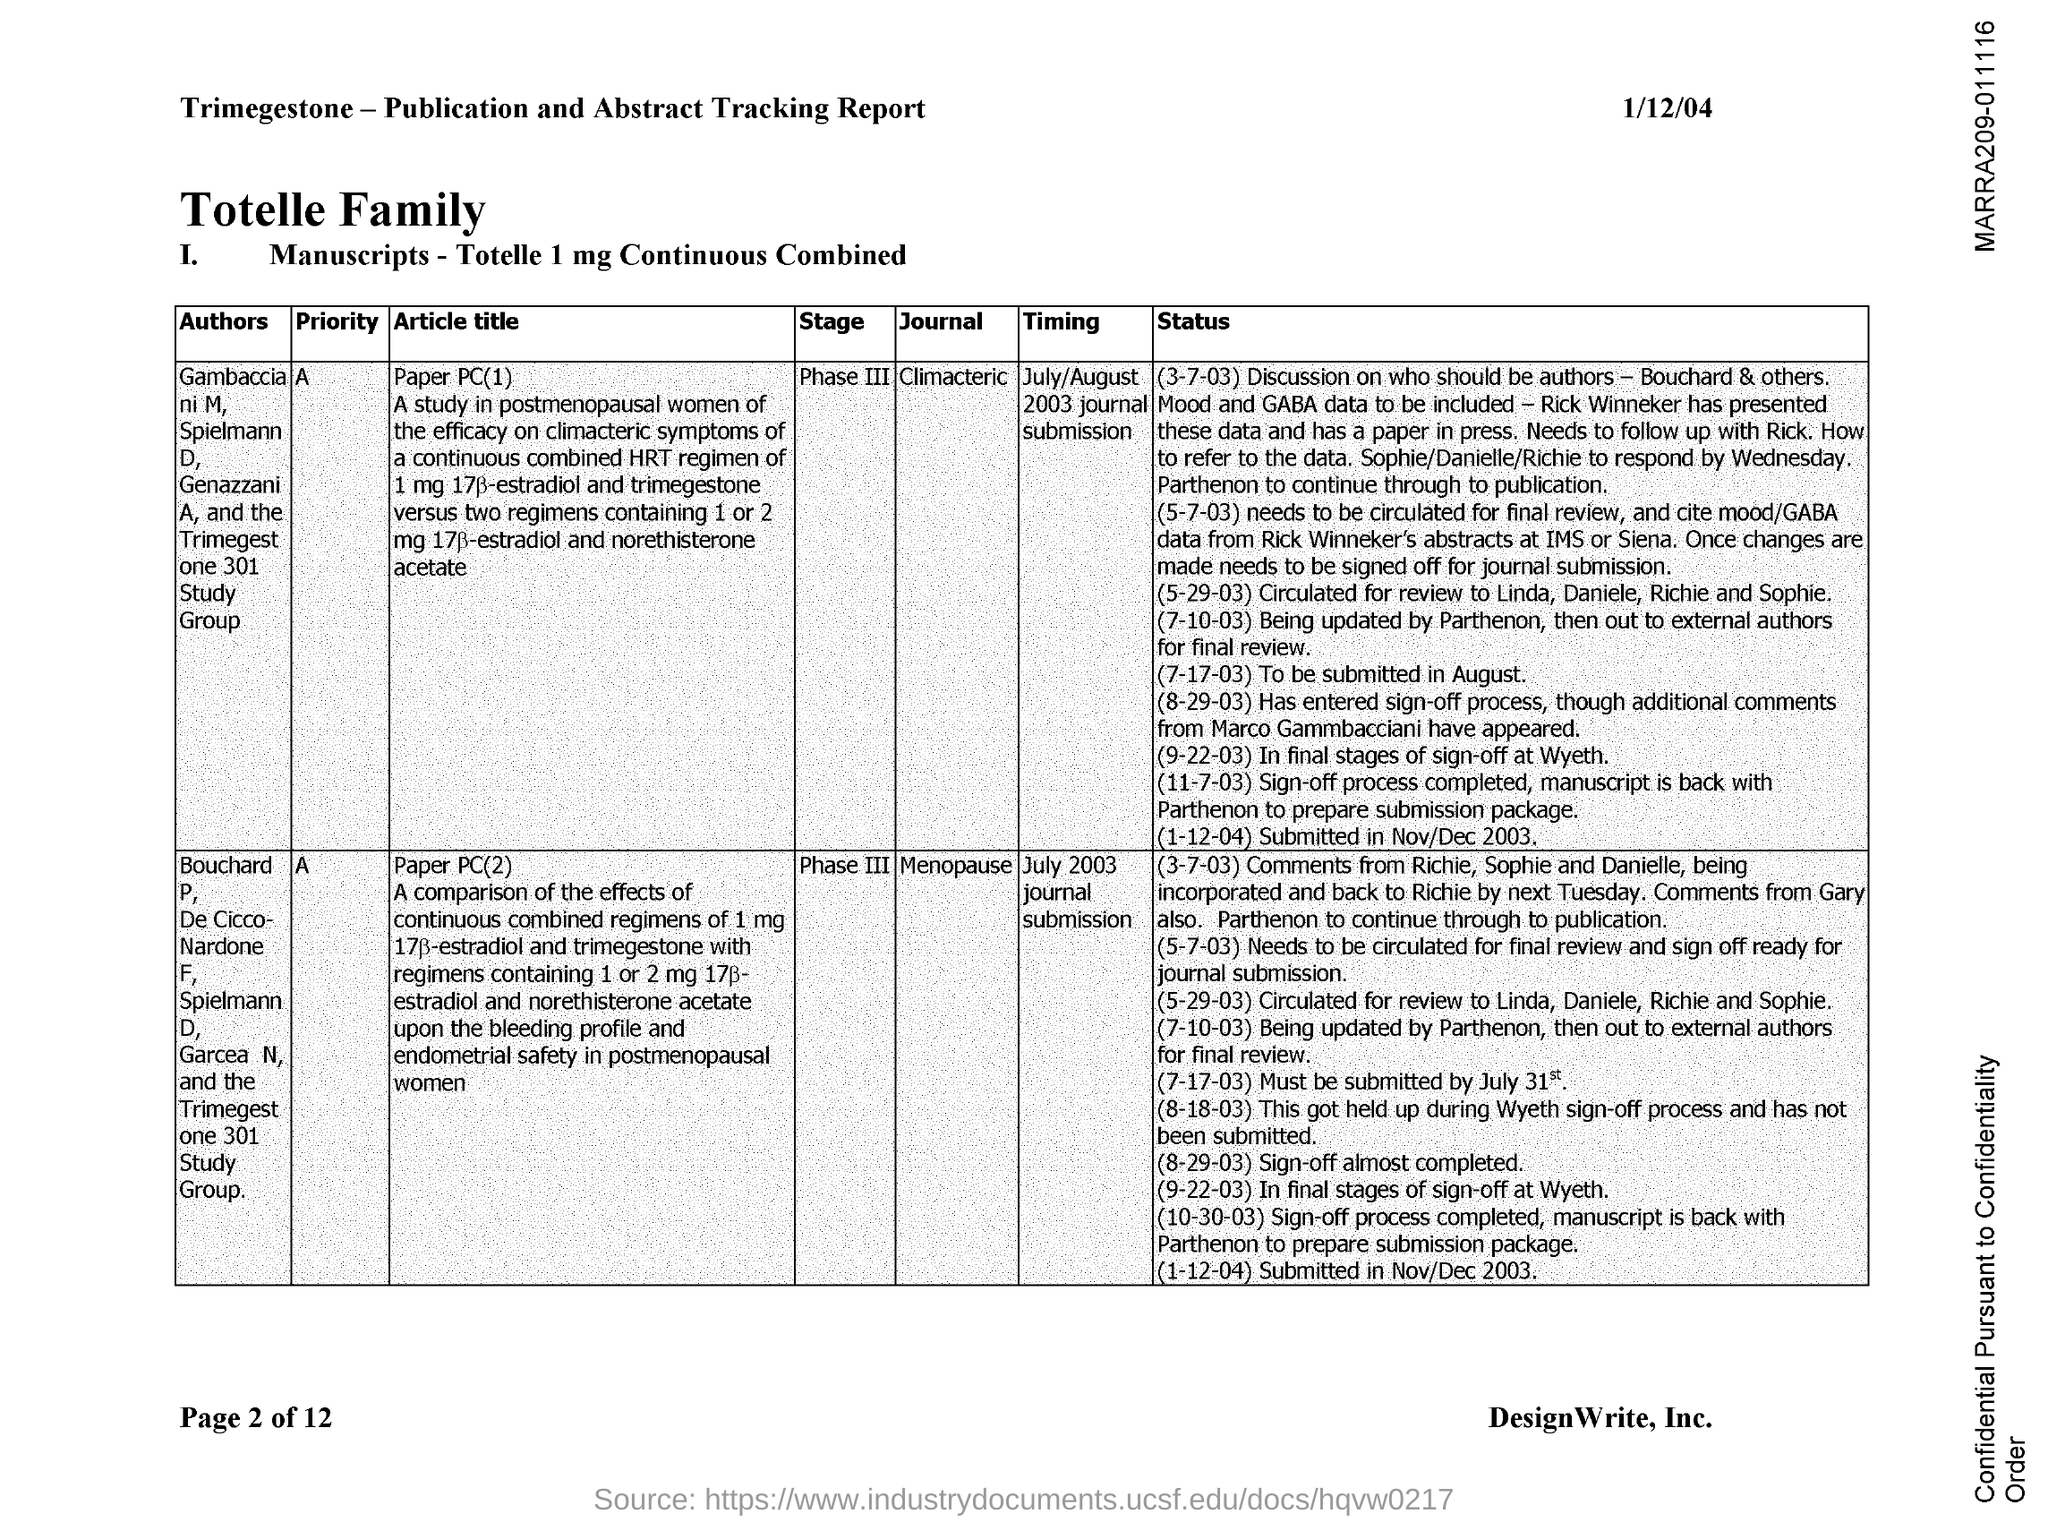What is the date mentioned in the document?
Offer a very short reply. 1/12/04. What is the name of the journal whose Article title is paper PC(1)?
Keep it short and to the point. Climacteric. What is the name of the journal whose Article title is paper PC(2)?
Ensure brevity in your answer.  Menopause. 